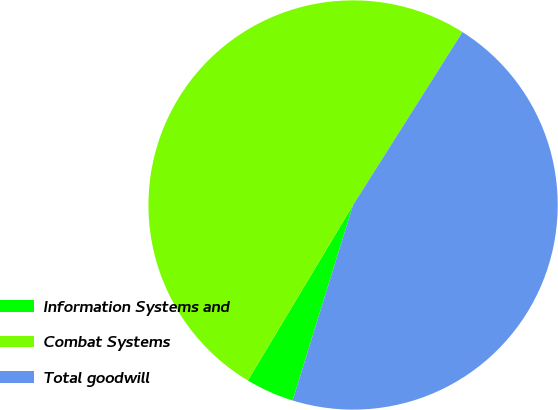Convert chart to OTSL. <chart><loc_0><loc_0><loc_500><loc_500><pie_chart><fcel>Information Systems and<fcel>Combat Systems<fcel>Total goodwill<nl><fcel>3.82%<fcel>50.38%<fcel>45.8%<nl></chart> 